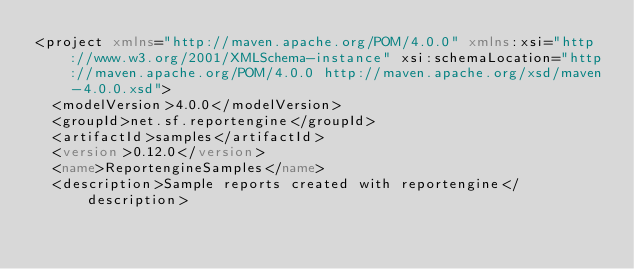Convert code to text. <code><loc_0><loc_0><loc_500><loc_500><_XML_><project xmlns="http://maven.apache.org/POM/4.0.0" xmlns:xsi="http://www.w3.org/2001/XMLSchema-instance" xsi:schemaLocation="http://maven.apache.org/POM/4.0.0 http://maven.apache.org/xsd/maven-4.0.0.xsd">
  <modelVersion>4.0.0</modelVersion>
  <groupId>net.sf.reportengine</groupId>
  <artifactId>samples</artifactId>
  <version>0.12.0</version>
  <name>ReportengineSamples</name>
  <description>Sample reports created with reportengine</description>
  </code> 